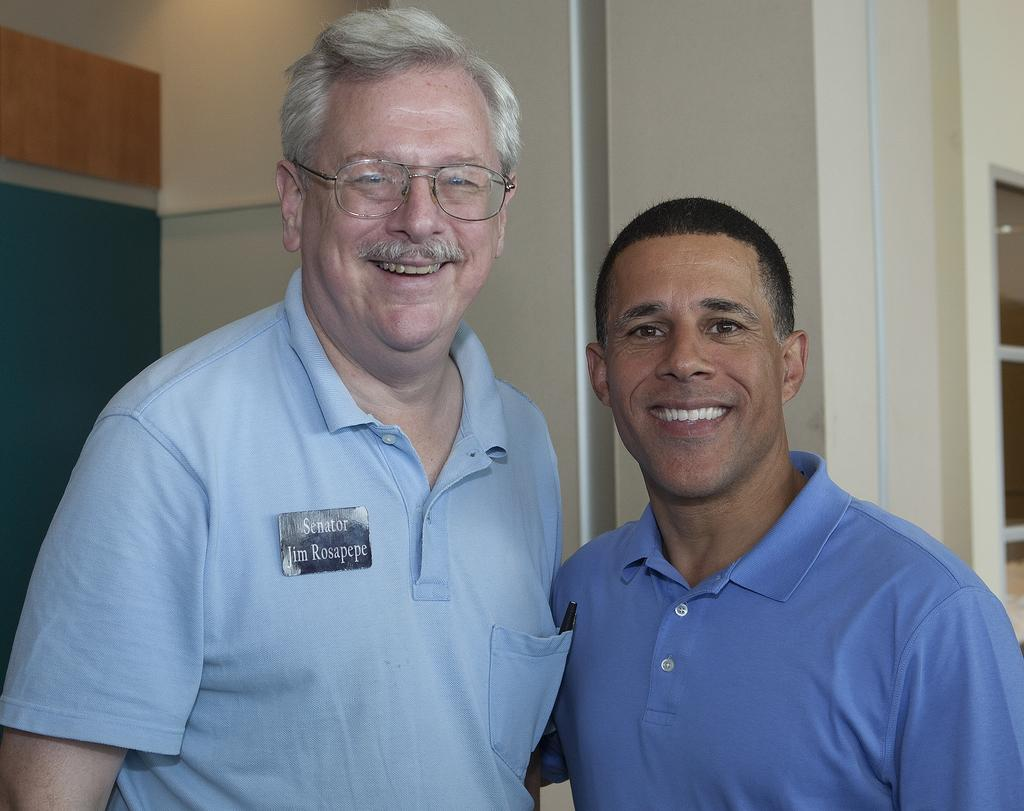How many people are in the image? There are two persons in the image. What is the facial expression of the persons? The persons are smiling. What can be seen behind the persons in the image? There is a wall visible behind the persons. Are there any fairies visible in the image? No, there are no fairies present in the image. What type of hall can be seen in the image? There is no hall visible in the image; it only features two persons and a wall in the background. 